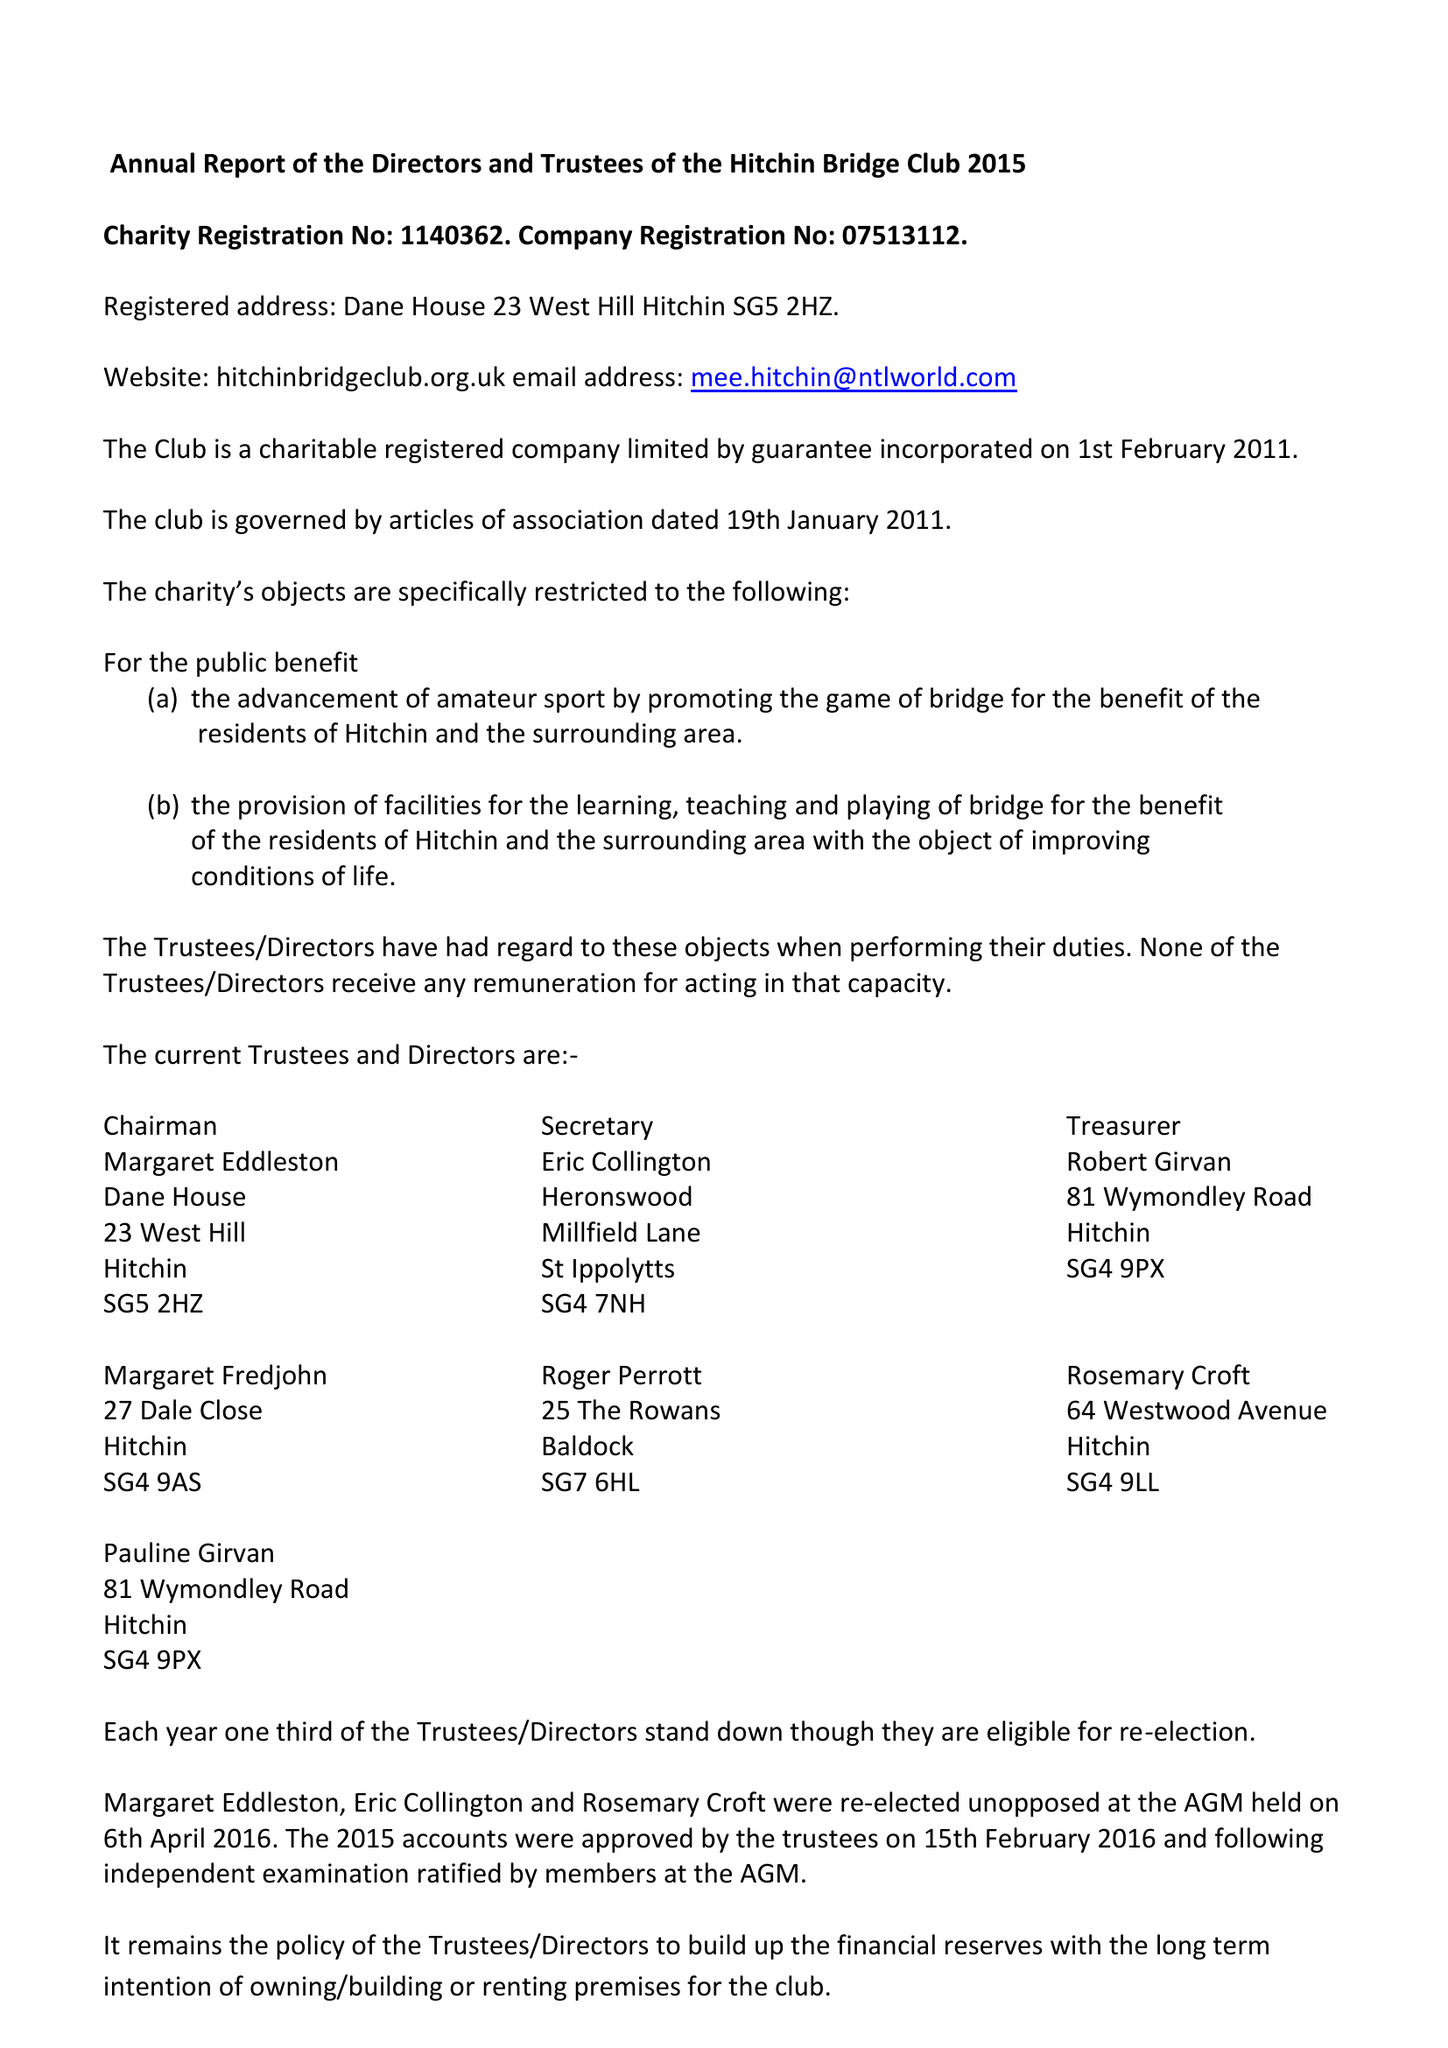What is the value for the address__street_line?
Answer the question using a single word or phrase. None 